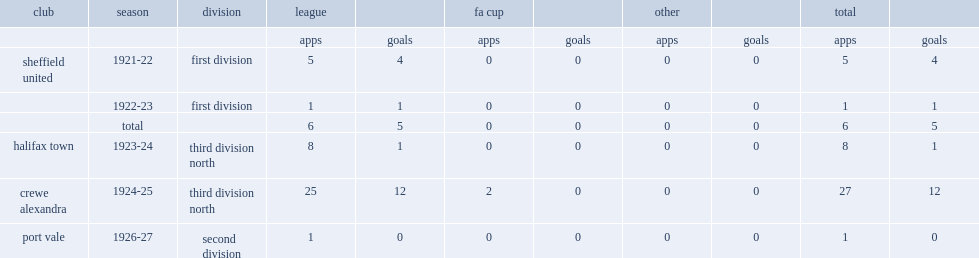Which club did percy oldacre join and score five goals in six first division games in the 1921-22 and 1922-23 seasons? Sheffield united. 